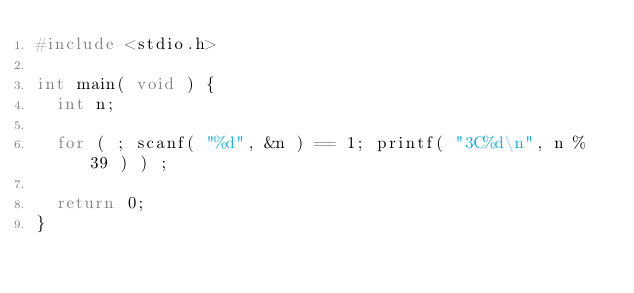<code> <loc_0><loc_0><loc_500><loc_500><_C_>#include <stdio.h>

int main( void ) {
	int n;

	for ( ; scanf( "%d", &n ) == 1; printf( "3C%d\n", n % 39 ) ) ;

	return 0;
}</code> 